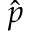Convert formula to latex. <formula><loc_0><loc_0><loc_500><loc_500>\hat { p }</formula> 